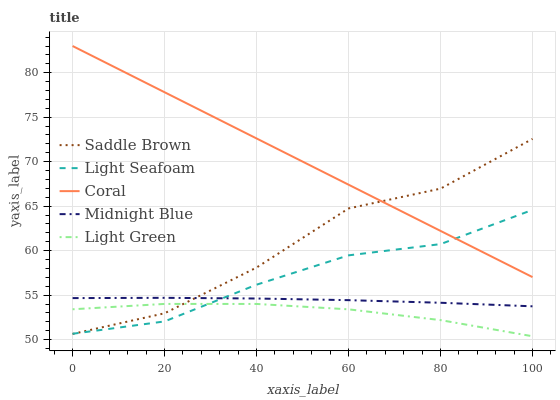Does Light Seafoam have the minimum area under the curve?
Answer yes or no. No. Does Light Seafoam have the maximum area under the curve?
Answer yes or no. No. Is Light Seafoam the smoothest?
Answer yes or no. No. Is Light Seafoam the roughest?
Answer yes or no. No. Does Light Seafoam have the lowest value?
Answer yes or no. No. Does Light Seafoam have the highest value?
Answer yes or no. No. Is Midnight Blue less than Coral?
Answer yes or no. Yes. Is Coral greater than Light Green?
Answer yes or no. Yes. Does Midnight Blue intersect Coral?
Answer yes or no. No. 